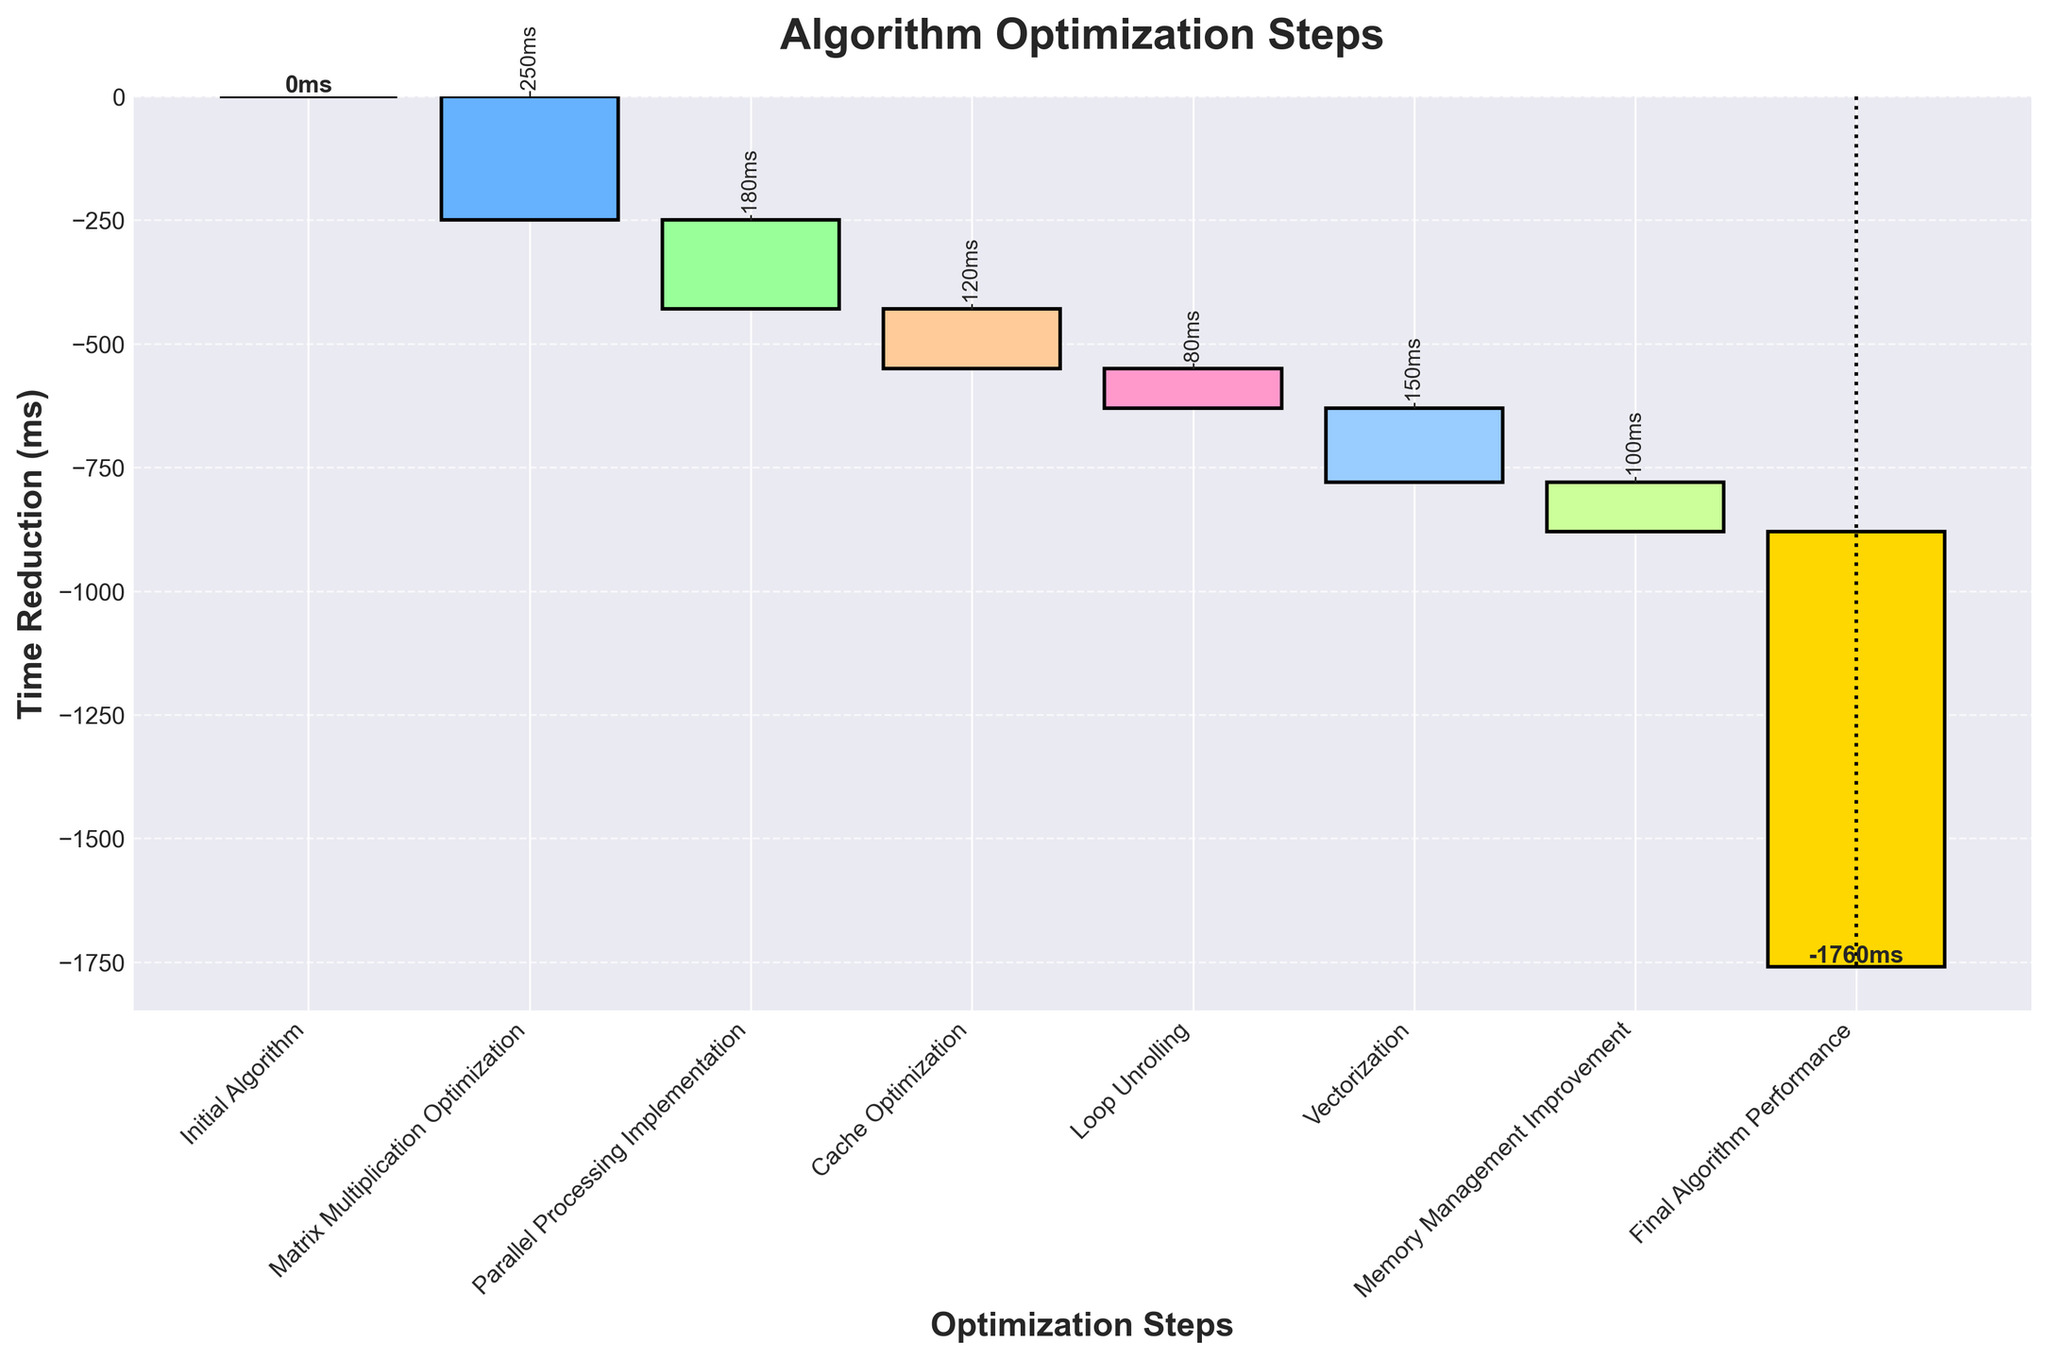What's the title of the chart? The title of the chart is prominently displayed at the top. It's written in a bold font to help users easily understand the main topic of the chart.
Answer: Algorithm Optimization Steps What is the time reduction of the Matrix Multiplication Optimization step? To find the time reduction for this step, locate the corresponding bar and read the label showing the value. The text rotation also highlights the value clearly.
Answer: -250 ms How many optimization steps are shown before reaching the Final Algorithm Performance? Count the steps listed on the x-axis before "Final Algorithm Performance". This includes both the initial and each optimization step.
Answer: 6 steps What is the cumulative time reduction after Parallel Processing Implementation and Cache Optimization are applied? First, identify the individual time reductions for the steps (-180 ms for Parallel Processing and -120 ms for Cache Optimization). Sum these values: -180 + (-120) = -300. Add this to the cumulative value after Matrix Multiplication Optimization (-250): -250 + -300 = -550 ms.
Answer: -550 ms Which optimization step contributed the most significant time reduction? Compare the values for each step by identifying the most negative reduction value. The step with the largest absolute value represents the most significant reduction.
Answer: Matrix Multiplication Optimization (-250 ms) Do Loop Unrolling and Memory Management Improvement combined result in a greater or lesser reduction than Vectorization? Add the reductions for Loop Unrolling and Memory Management: -80 + -100 = -180 ms. Compare this combined value to the reduction from Vectorization: -180 ms vs. -150 ms.
Answer: Greater reduction (-180 ms) What is the cumulative time reduction value displayed next to the Final Algorithm Performance step? The cumulative time reduction for the final step is shown above the corresponding bar at the end of the chart.
Answer: -880 ms Which step results in the smallest time reduction? Compare the absolute values of reductions for each step and determine the smallest magnitude.
Answer: Loop Unrolling (-80 ms) By how much did Parallel Processing Implementation reduce the time compared to Cache Optimization? Find the reductions for Parallel Processing (-180 ms) and Cache Optimization (-120 ms). Compute the difference: -180 - (-120) = -60 ms.
Answer: 60 ms 